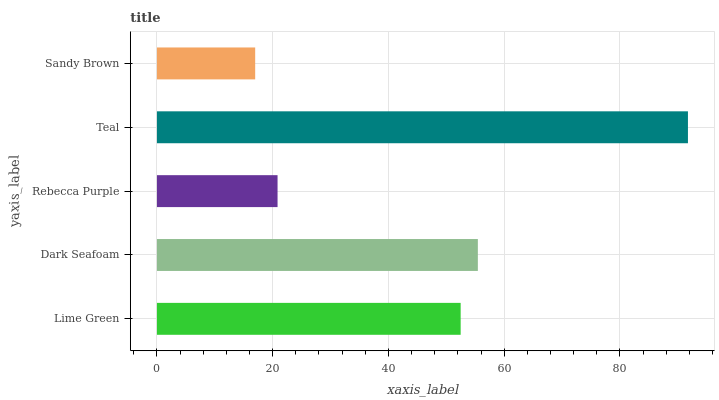Is Sandy Brown the minimum?
Answer yes or no. Yes. Is Teal the maximum?
Answer yes or no. Yes. Is Dark Seafoam the minimum?
Answer yes or no. No. Is Dark Seafoam the maximum?
Answer yes or no. No. Is Dark Seafoam greater than Lime Green?
Answer yes or no. Yes. Is Lime Green less than Dark Seafoam?
Answer yes or no. Yes. Is Lime Green greater than Dark Seafoam?
Answer yes or no. No. Is Dark Seafoam less than Lime Green?
Answer yes or no. No. Is Lime Green the high median?
Answer yes or no. Yes. Is Lime Green the low median?
Answer yes or no. Yes. Is Rebecca Purple the high median?
Answer yes or no. No. Is Rebecca Purple the low median?
Answer yes or no. No. 